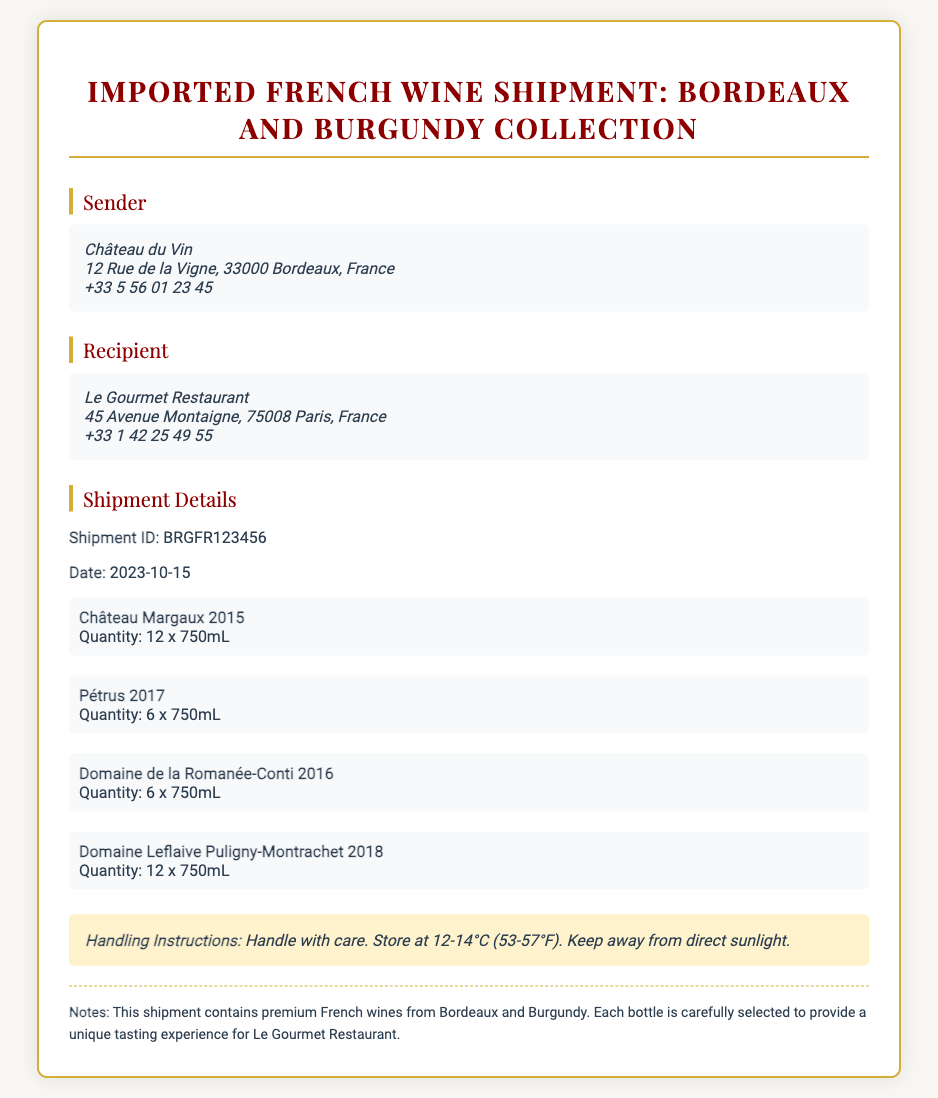What is the shipment ID? The shipment ID is specified under "Shipment Details" in the document.
Answer: BRGFR123456 Who is the sender of the shipment? The sender's details are provided in the "Sender" section of the document.
Answer: Château du Vin What is the recipient's address? The recipient's address is located in the "Recipient" section of the document.
Answer: 45 Avenue Montaigne, 75008 Paris, France How many bottles of Château Margaux 2015 were shipped? The quantity of Château Margaux 2015 is detailed in the shipment list of wines.
Answer: 12 x 750mL On what date was the shipment made? The date of the shipment is listed in the "Shipment Details" section of the document.
Answer: 2023-10-15 What is the total quantity of Domaine Leflaive Puligny-Montrachet 2018? The quantity for this wine is mentioned in the list of wines in the document.
Answer: 12 x 750mL What are the handling instructions for the shipment? Handling instructions are outlined in the designated "Handling Instructions" section.
Answer: Handle with care. Store at 12-14°C (53-57°F) Which wine is a product of Burgundy? The list of wines includes one that is specifically from Burgundy, indicated within the collection.
Answer: Domaine de la Romanée-Conti 2016 What theme does the shipment highlight? The shipment focuses on a collection of premium wines, as described in the notes within the document.
Answer: French wines from Bordeaux and Burgundy 